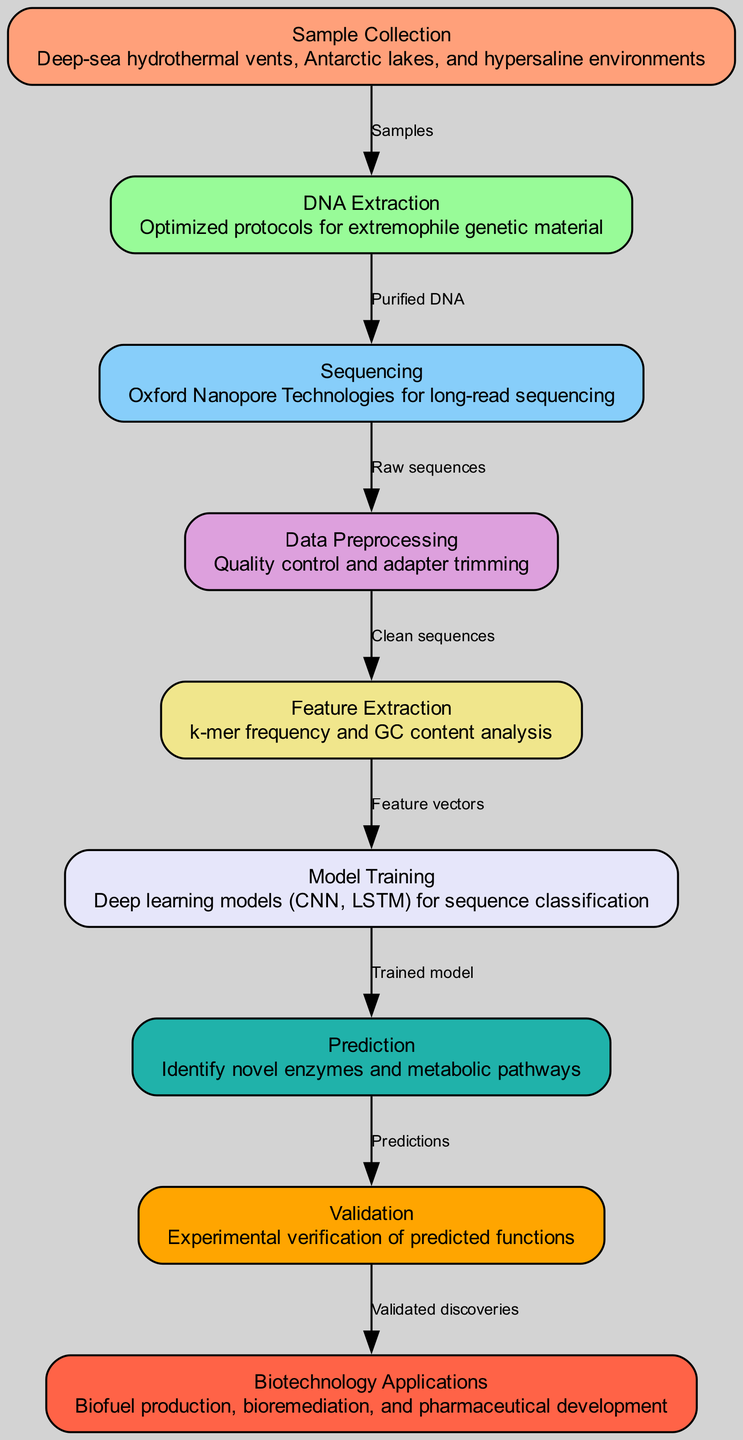What is the first step in the pipeline? The first step in the pipeline is "Sample Collection," which involves collecting samples from environments like deep-sea hydrothermal vents, Antarctic lakes, and hypersaline environments.
Answer: Sample Collection How many nodes are present in the diagram? By counting the individual labeled nodes, we find that there are nine nodes present in the diagram that represent various stages of the machine learning pipeline.
Answer: Nine What is the output of the "Validation" node? The output of the "Validation" node is "Validated discoveries," indicating that this step involves confirming the experimental verification of predicted functions from the analysis.
Answer: Validated discoveries Which technique is used during the "Model Training" phase? "Deep learning models (CNN, LSTM)" are used during the "Model Training" phase for sequence classification, as described in the corresponding node.
Answer: Deep learning models (CNN, LSTM) What step follows "Prediction"? "Validation" follows "Prediction" in the pipeline, suggesting that predictions made through the analysis are experimentally verified in this subsequent step.
Answer: Validation What type of sequencing is used in the pipeline? The pipeline utilizes "Oxford Nanopore Technologies for long-read sequencing," as indicated in the "Sequencing" node's description.
Answer: Oxford Nanopore Technologies What is the primary focus of the "Feature Extraction" step? The primary focus of the "Feature Extraction" step is on "k-mer frequency and GC content analysis," which is critical for preparing the data for model training.
Answer: k-mer frequency and GC content analysis How do the edges represent the flow of data? The edges in the diagram represent the flow of data between the nodes, indicating that each step in the pipeline takes input from the previous step and outputs data to the next step.
Answer: Flow of data between nodes What are the potential applications listed in the diagram? The potential applications listed in the diagram include "Biofuel production, bioremediation, and pharmaceutical development," showcasing the practical implications of the research.
Answer: Biofuel production, bioremediation, and pharmaceutical development 